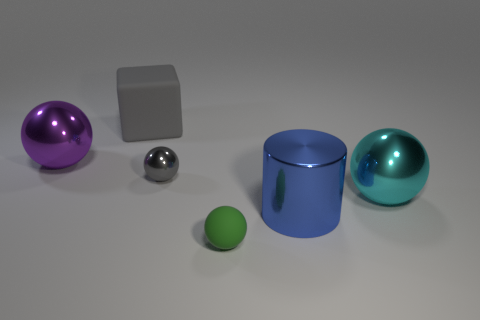Add 4 gray matte blocks. How many objects exist? 10 Subtract all spheres. How many objects are left? 2 Add 6 big purple things. How many big purple things are left? 7 Add 1 metal balls. How many metal balls exist? 4 Subtract 0 brown cylinders. How many objects are left? 6 Subtract all cyan spheres. Subtract all green rubber balls. How many objects are left? 4 